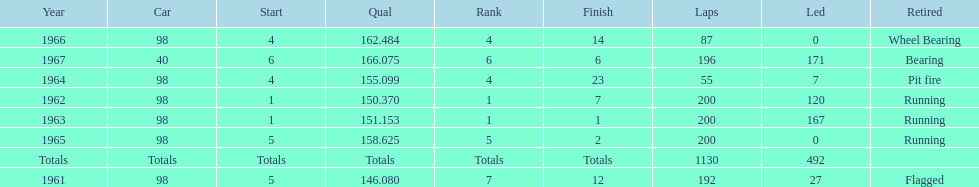What car ranked #1 from 1962-1963? 98. Can you give me this table as a dict? {'header': ['Year', 'Car', 'Start', 'Qual', 'Rank', 'Finish', 'Laps', 'Led', 'Retired'], 'rows': [['1966', '98', '4', '162.484', '4', '14', '87', '0', 'Wheel Bearing'], ['1967', '40', '6', '166.075', '6', '6', '196', '171', 'Bearing'], ['1964', '98', '4', '155.099', '4', '23', '55', '7', 'Pit fire'], ['1962', '98', '1', '150.370', '1', '7', '200', '120', 'Running'], ['1963', '98', '1', '151.153', '1', '1', '200', '167', 'Running'], ['1965', '98', '5', '158.625', '5', '2', '200', '0', 'Running'], ['Totals', 'Totals', 'Totals', 'Totals', 'Totals', 'Totals', '1130', '492', ''], ['1961', '98', '5', '146.080', '7', '12', '192', '27', 'Flagged']]} 